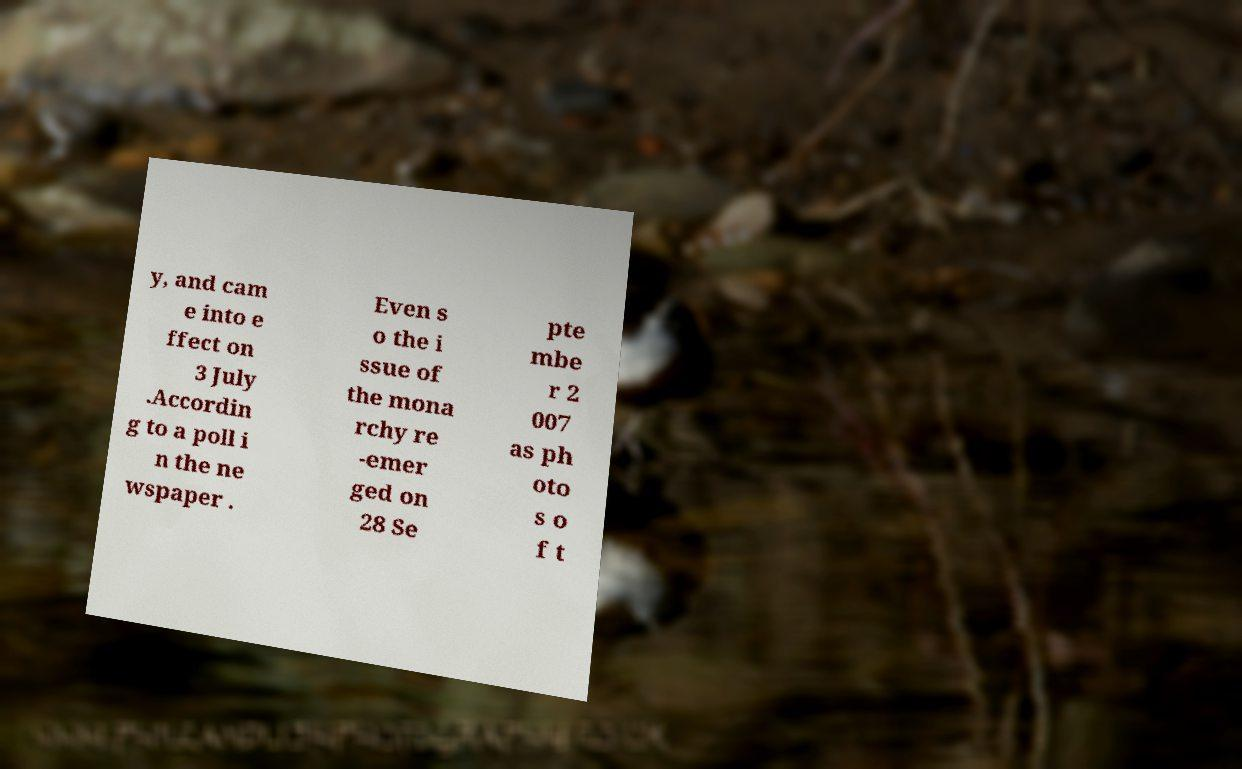There's text embedded in this image that I need extracted. Can you transcribe it verbatim? y, and cam e into e ffect on 3 July .Accordin g to a poll i n the ne wspaper . Even s o the i ssue of the mona rchy re -emer ged on 28 Se pte mbe r 2 007 as ph oto s o f t 